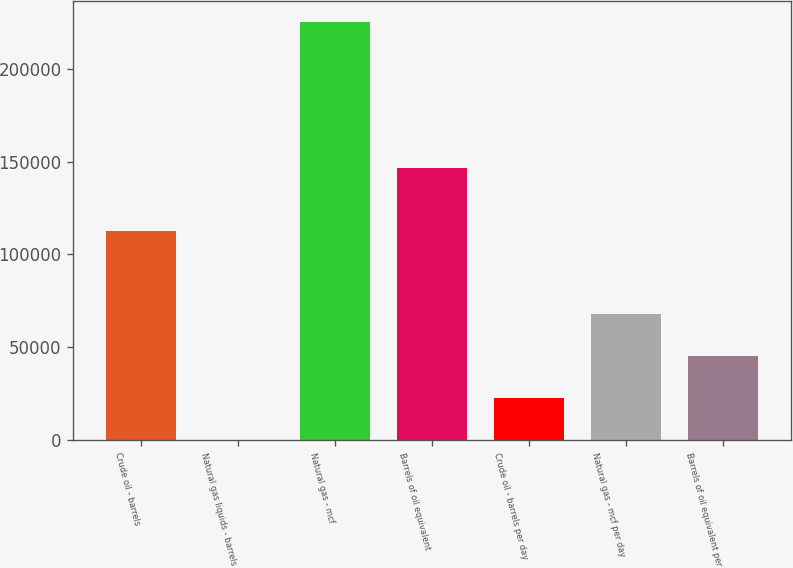Convert chart to OTSL. <chart><loc_0><loc_0><loc_500><loc_500><bar_chart><fcel>Crude oil - barrels<fcel>Natural gas liquids - barrels<fcel>Natural gas - mcf<fcel>Barrels of oil equivalent<fcel>Crude oil - barrels per day<fcel>Natural gas - mcf per day<fcel>Barrels of oil equivalent per<nl><fcel>112813<fcel>19<fcel>225607<fcel>146510<fcel>22577.8<fcel>67695.4<fcel>45136.6<nl></chart> 